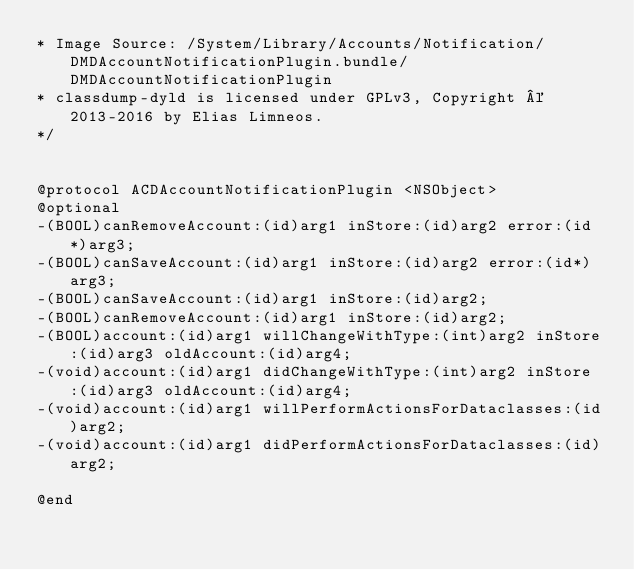<code> <loc_0><loc_0><loc_500><loc_500><_C_>* Image Source: /System/Library/Accounts/Notification/DMDAccountNotificationPlugin.bundle/DMDAccountNotificationPlugin
* classdump-dyld is licensed under GPLv3, Copyright © 2013-2016 by Elias Limneos.
*/


@protocol ACDAccountNotificationPlugin <NSObject>
@optional
-(BOOL)canRemoveAccount:(id)arg1 inStore:(id)arg2 error:(id*)arg3;
-(BOOL)canSaveAccount:(id)arg1 inStore:(id)arg2 error:(id*)arg3;
-(BOOL)canSaveAccount:(id)arg1 inStore:(id)arg2;
-(BOOL)canRemoveAccount:(id)arg1 inStore:(id)arg2;
-(BOOL)account:(id)arg1 willChangeWithType:(int)arg2 inStore:(id)arg3 oldAccount:(id)arg4;
-(void)account:(id)arg1 didChangeWithType:(int)arg2 inStore:(id)arg3 oldAccount:(id)arg4;
-(void)account:(id)arg1 willPerformActionsForDataclasses:(id)arg2;
-(void)account:(id)arg1 didPerformActionsForDataclasses:(id)arg2;

@end

</code> 